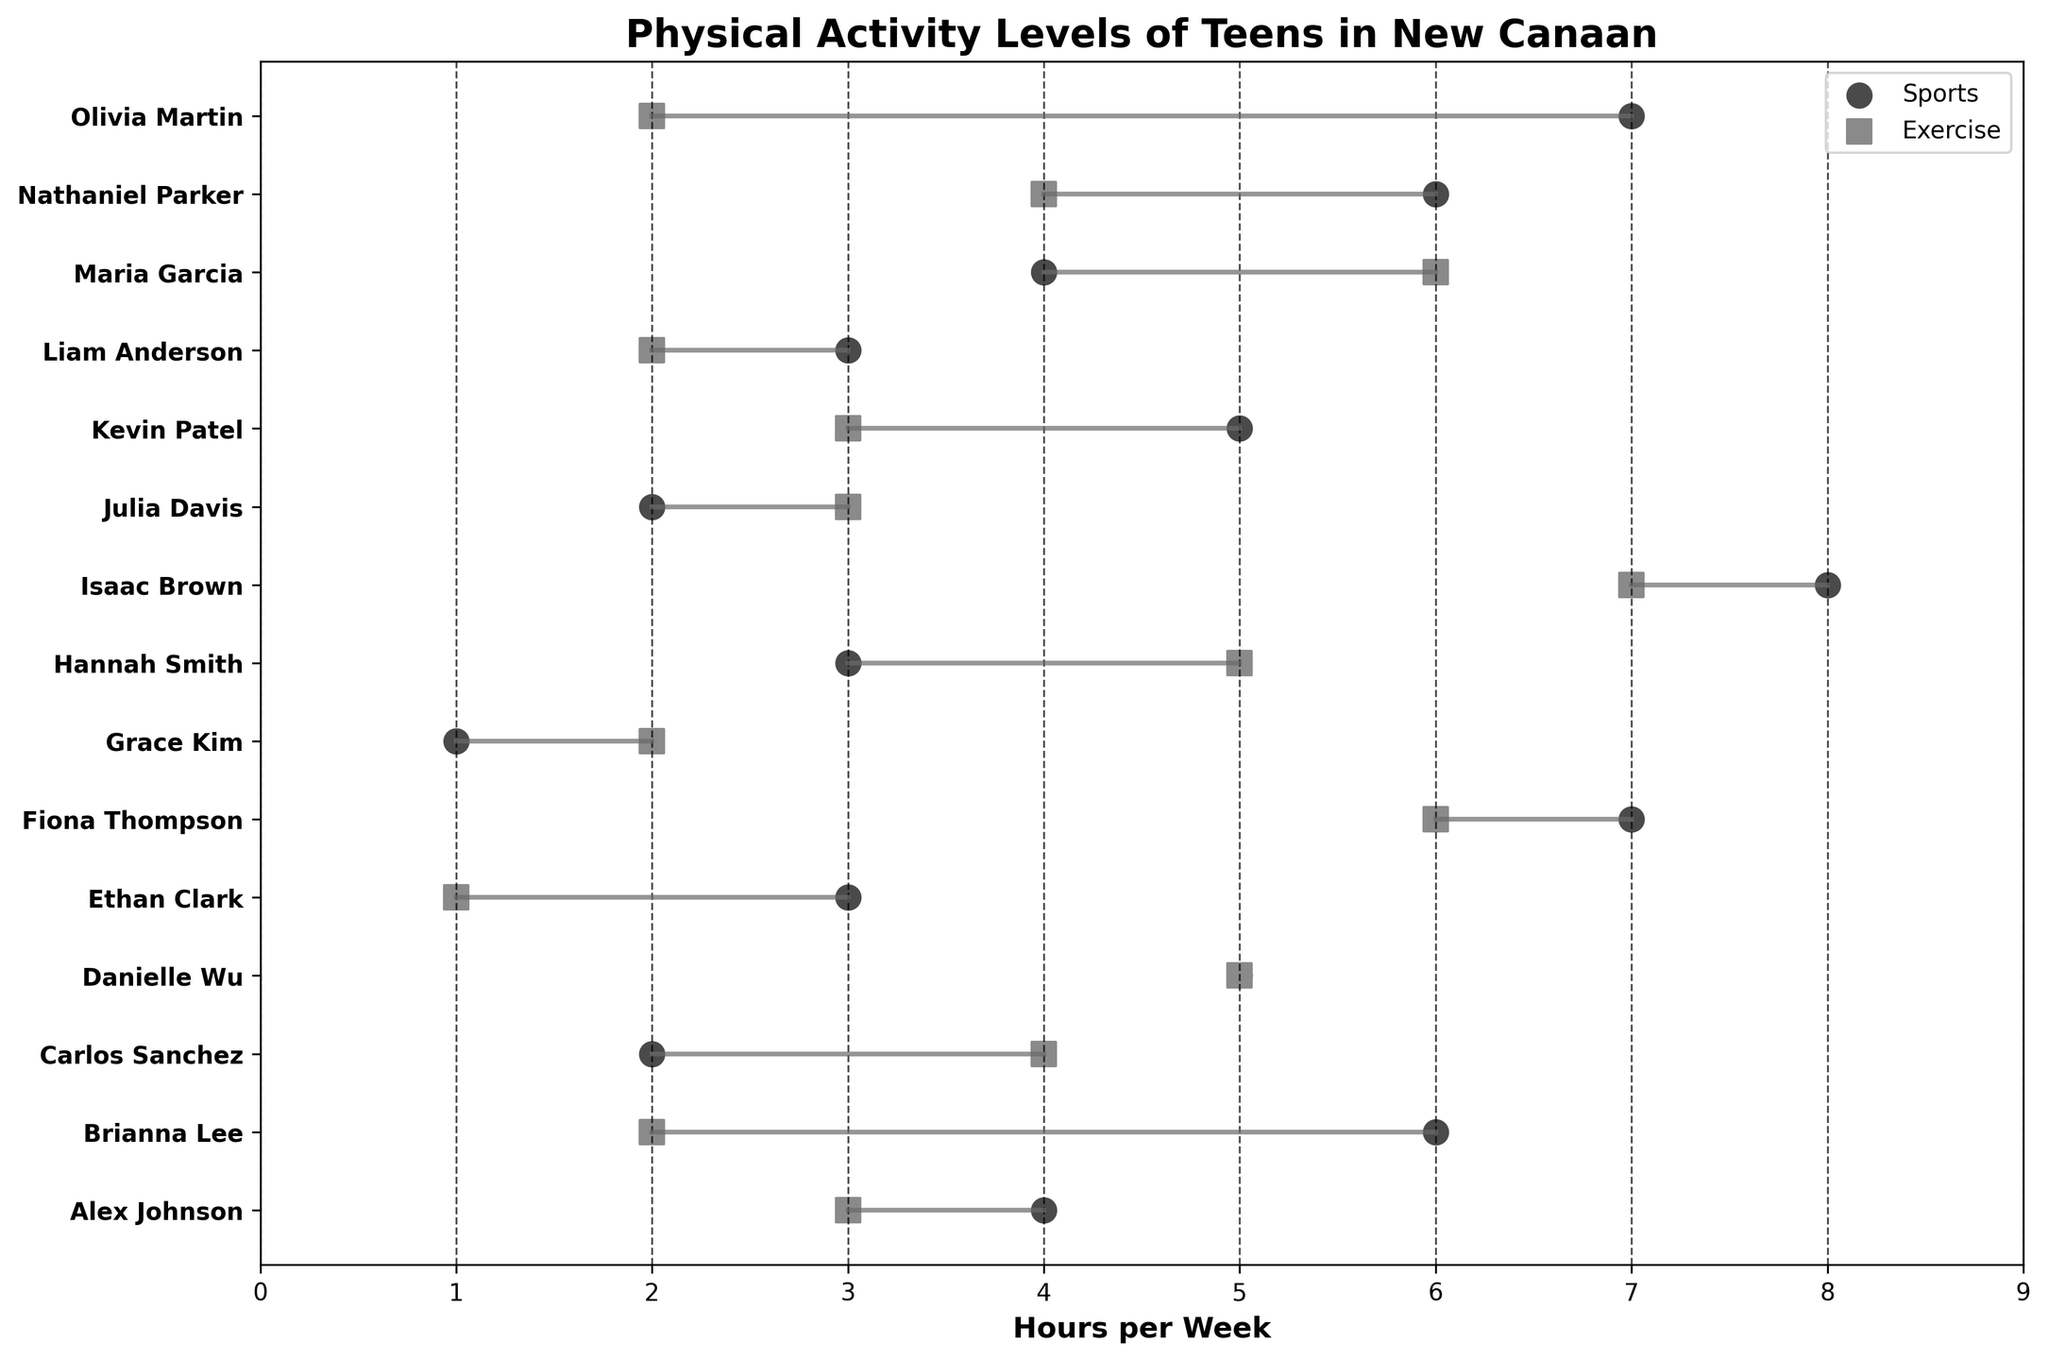What is the title of the figure? The title of the figure is displayed at the top of the plot. In this case, it reads "Physical Activity Levels of Teens in New Canaan".
Answer: Physical Activity Levels of Teens in New Canaan Which teen spends the most hours on sports? By looking at the scatter plot, the teen with the highest value on the sports axis is Isaac Brown, with 8 hours.
Answer: Isaac Brown How many hours does Fiona Thompson spend on exercise? Fiona Thompson is represented by a dot and square pair. The square for exercise is located at 6 on the x-axis.
Answer: 6 Which two teens have the same hours spent on exercise? By comparing the squares along the exercise axis, both Danielle Wu and Kevin Patel have their squares at the same value, which is 3 hours.
Answer: Danielle Wu and Kevin Patel What is the total number of hours for sports and exercise for Nathaniel Parker? Nathaniel Parker has 6 hours on sports and 4 hours on exercise. Summing these values gives 10 hours in total.
Answer: 10 Who has a greater difference between sports and exercise hours, Maria Garcia or Olivia Martin? To determine the difference, subtract the exercise hours from the sports hours:
Maria Garcia: 4 - 6 = -2 (absolute value 2 hours difference)
Olivia Martin: 7 - 2 = 5 hours difference.
Olivia Martin has a greater difference.
Answer: Olivia Martin List all teens who have equal hours in both sports and exercise. By looking for teens where the circle and square overlap on the horizontal axis, Danielle Wu is the only teen with equal hours for both sports and exercise (5 hours each).
Answer: Danielle Wu Which teen spends the least time on sports? Grace Kim spends the least time on sports as indicated by the point at 1 hour on the sports axis.
Answer: Grace Kim What is the average number of hours spent on exercise by all teens? To calculate the average, sum all the exercise hours and divide by the number of teens:
(3 + 2 + 4 + 5 + 1 + 6 + 2 + 5 + 7 + 3 + 3 + 2 + 6 + 4 + 2) = 55 hours.
There are 15 teens, so the average is 55/15 ≈ 3.67 hours.
Answer: 3.67 How many teens spend more time on exercise than on sports? By visually comparing the position of squares and circles for each teen, it can be seen that Carlos Sanchez, Hannah Smith, and Maria Garcia spend more hours on exercise than on sports, resulting in a total of 3 teens.
Answer: 3 